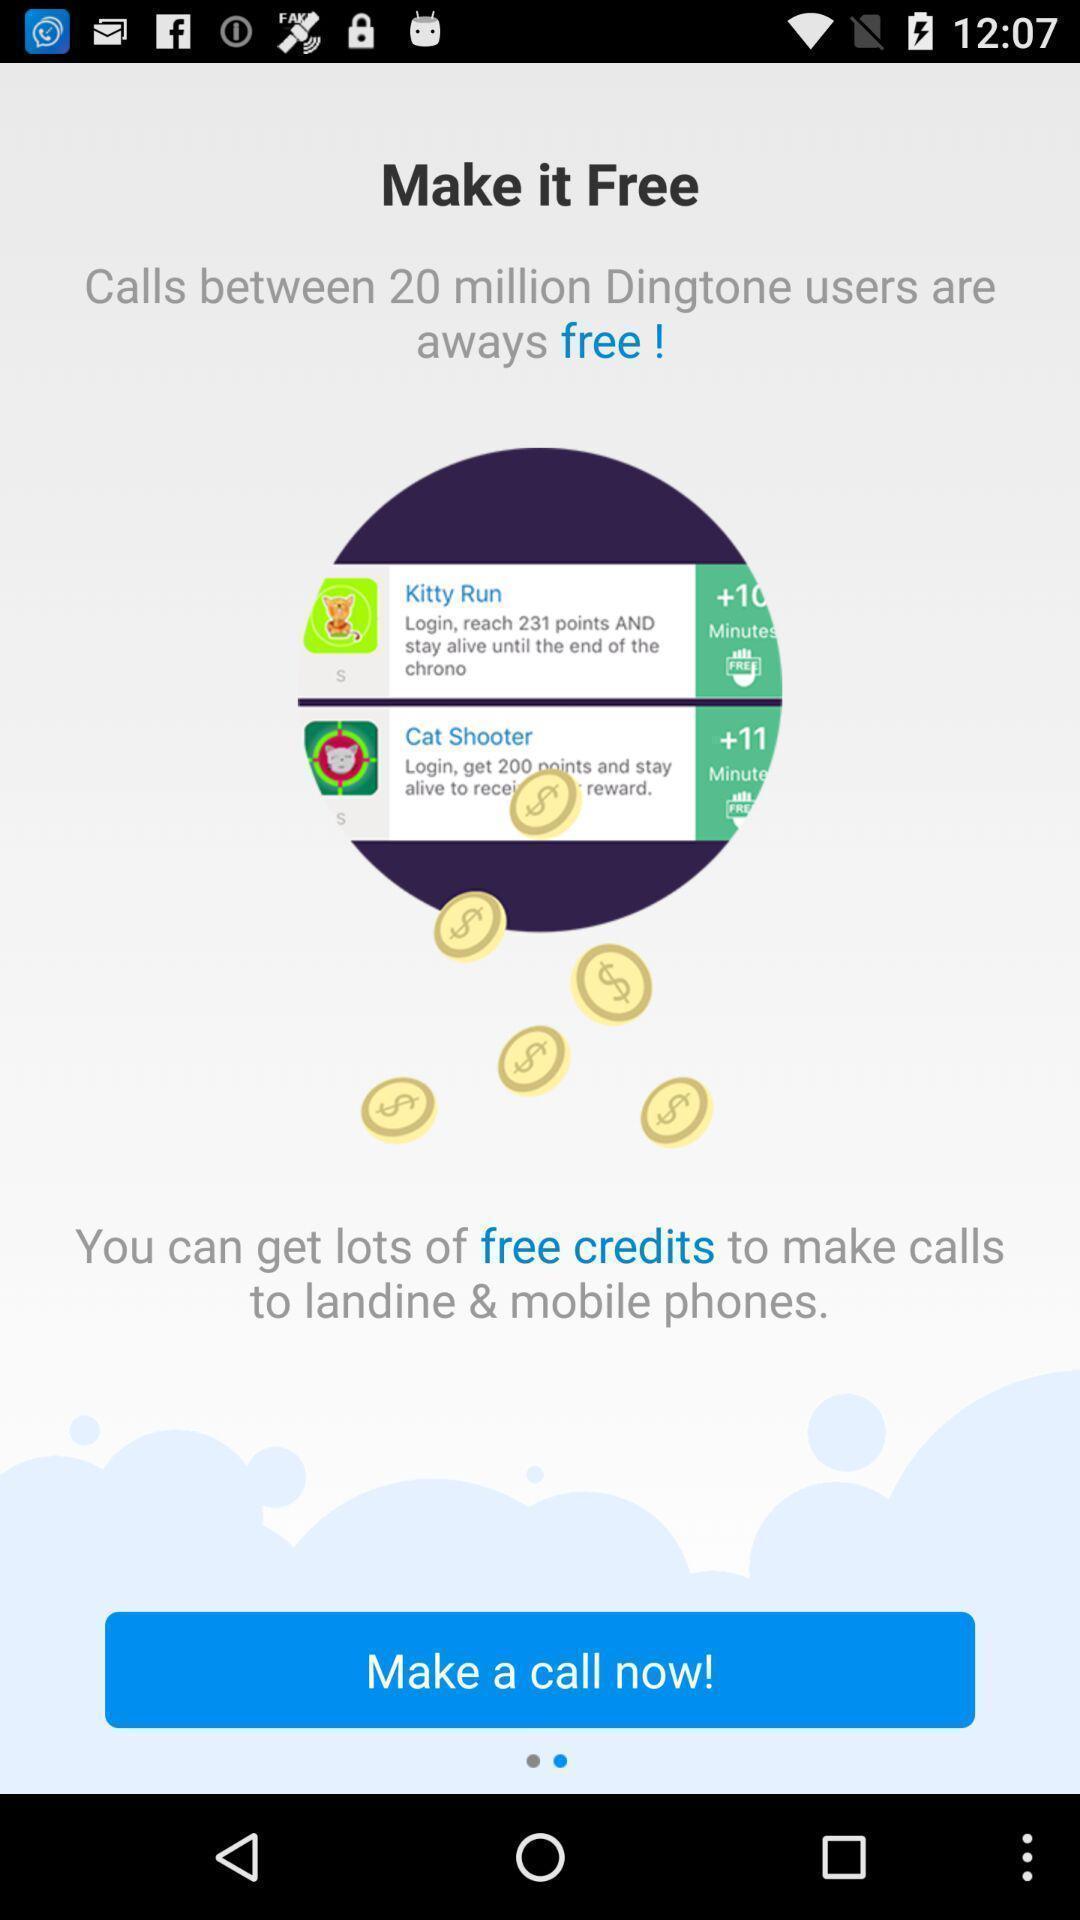Describe the visual elements of this screenshot. Screen displaying features information. 